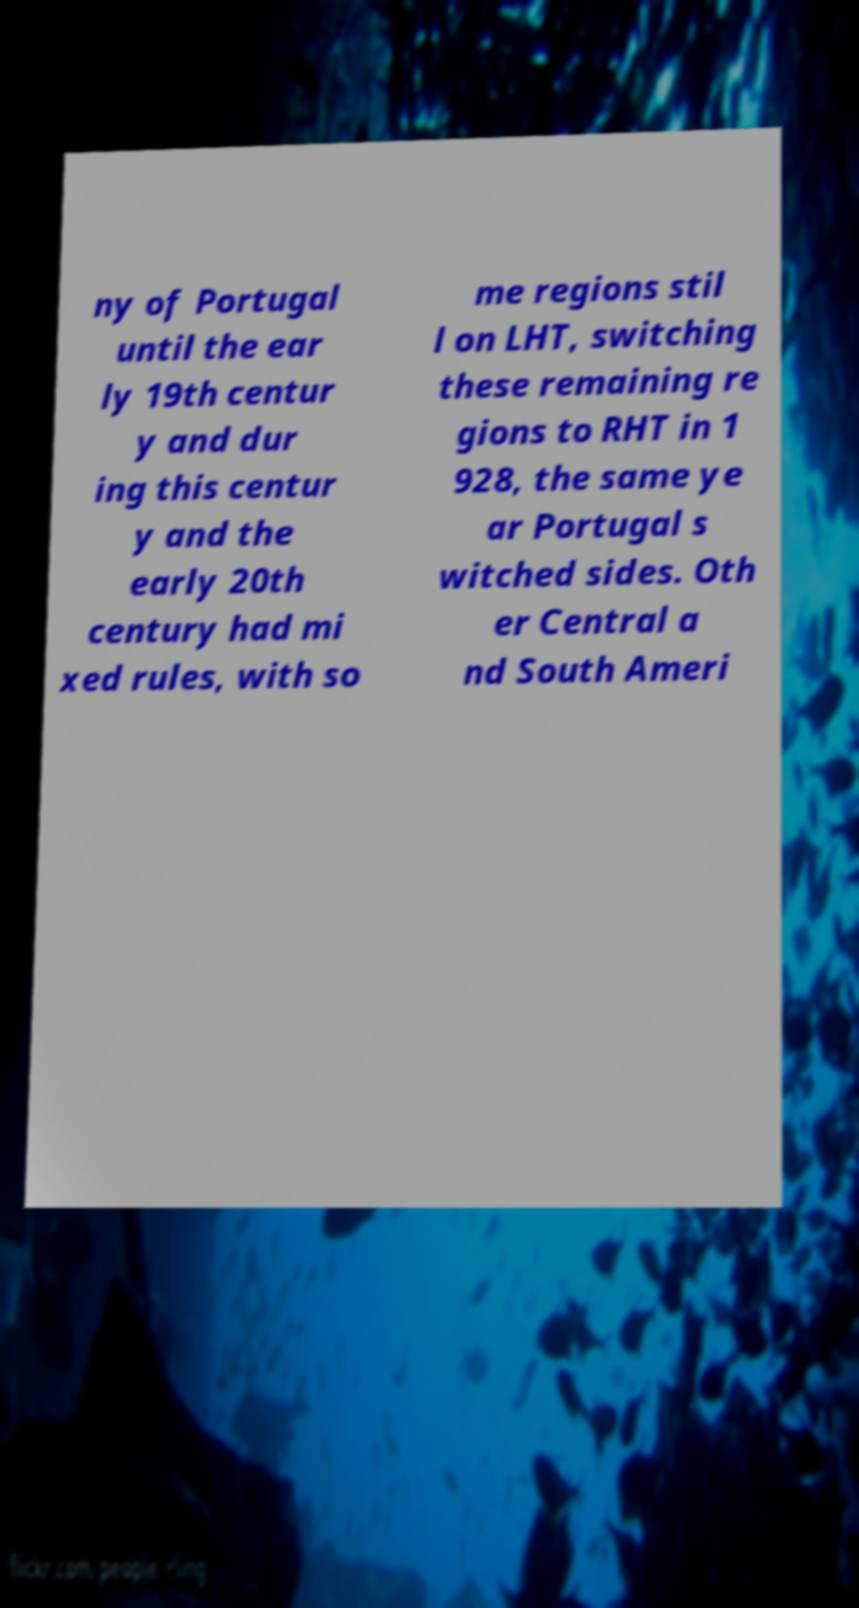Could you assist in decoding the text presented in this image and type it out clearly? ny of Portugal until the ear ly 19th centur y and dur ing this centur y and the early 20th century had mi xed rules, with so me regions stil l on LHT, switching these remaining re gions to RHT in 1 928, the same ye ar Portugal s witched sides. Oth er Central a nd South Ameri 